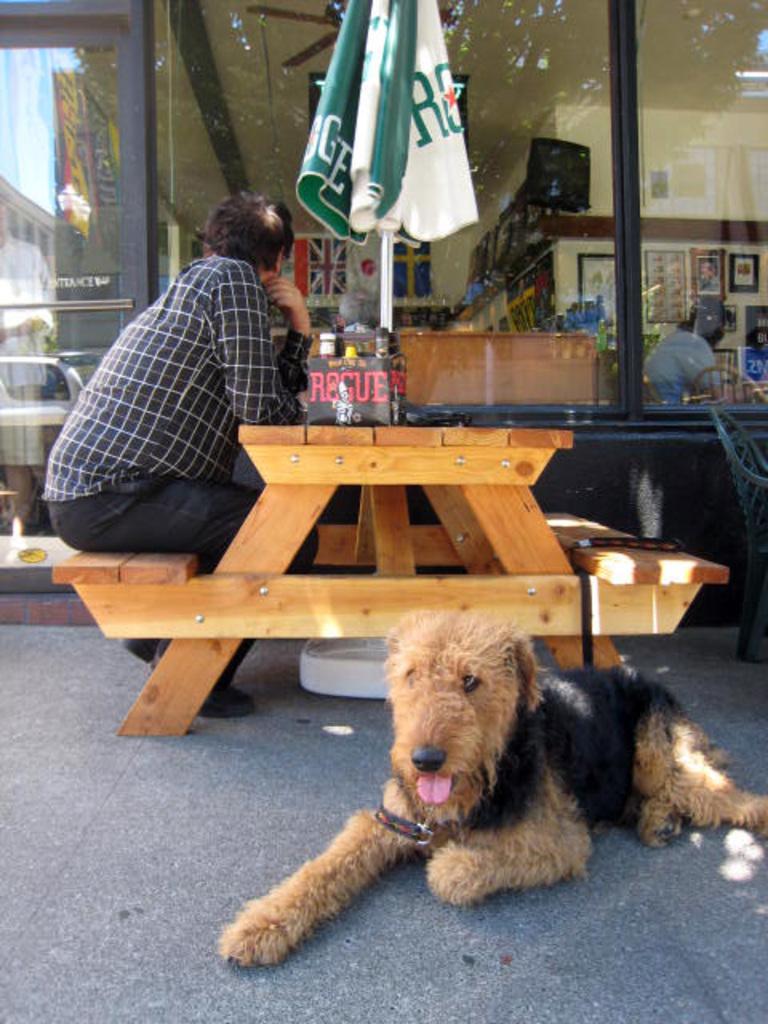Please provide a concise description of this image. In Front portion of the picture we can see a dog sitting on the floor. We can see a man sitting on a bench and there is a table. Through glass window we can see frames over a wall, person, flags. This is an umbrella. 